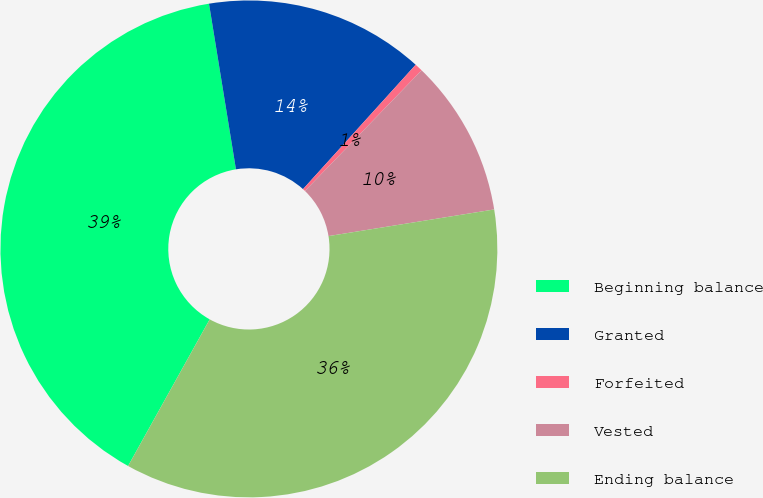Convert chart. <chart><loc_0><loc_0><loc_500><loc_500><pie_chart><fcel>Beginning balance<fcel>Granted<fcel>Forfeited<fcel>Vested<fcel>Ending balance<nl><fcel>39.35%<fcel>14.28%<fcel>0.52%<fcel>10.23%<fcel>35.62%<nl></chart> 